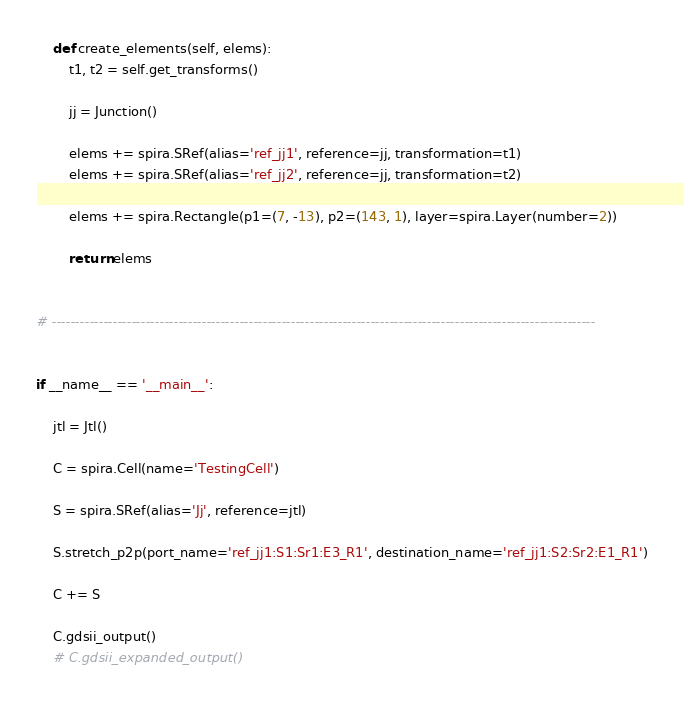<code> <loc_0><loc_0><loc_500><loc_500><_Python_>
    def create_elements(self, elems):
        t1, t2 = self.get_transforms()

        jj = Junction()

        elems += spira.SRef(alias='ref_jj1', reference=jj, transformation=t1)
        elems += spira.SRef(alias='ref_jj2', reference=jj, transformation=t2)

        elems += spira.Rectangle(p1=(7, -13), p2=(143, 1), layer=spira.Layer(number=2))

        return elems


# --------------------------------------------------------------------------------------------------------------------


if __name__ == '__main__':

    jtl = Jtl()
    
    C = spira.Cell(name='TestingCell')

    S = spira.SRef(alias='Jj', reference=jtl)

    S.stretch_p2p(port_name='ref_jj1:S1:Sr1:E3_R1', destination_name='ref_jj1:S2:Sr2:E1_R1')

    C += S

    C.gdsii_output()
    # C.gdsii_expanded_output()


</code> 